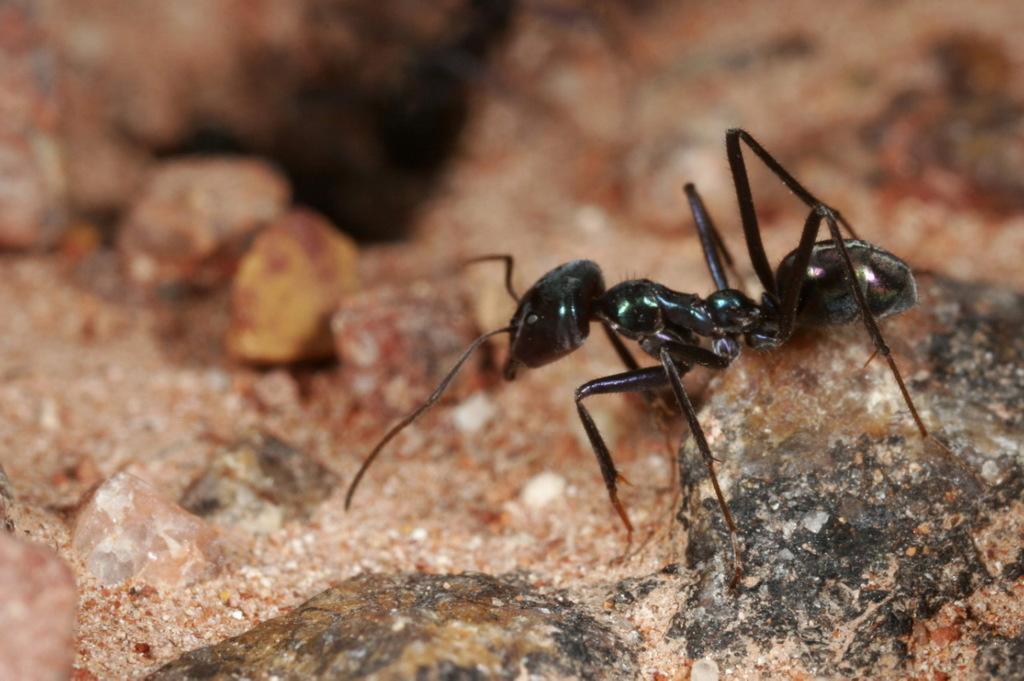In one or two sentences, can you explain what this image depicts? In this image we can see a black color pant, which might be on a rock. 